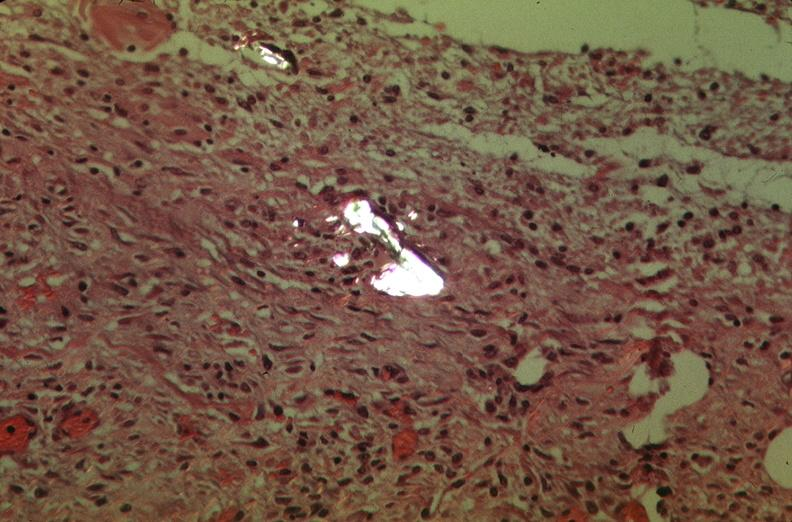was pneumocystis used to sclerose emphysematous lung, alpha-1 antitrypsin deficiency?
Answer the question using a single word or phrase. No 